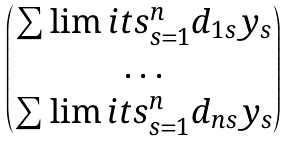<formula> <loc_0><loc_0><loc_500><loc_500>\begin{pmatrix} \sum \lim i t s _ { s = 1 } ^ { n } { d _ { 1 s } y _ { s } } \\ \dots \\ \sum \lim i t s _ { s = 1 } ^ { n } { d _ { n s } y _ { s } } \end{pmatrix}</formula> 